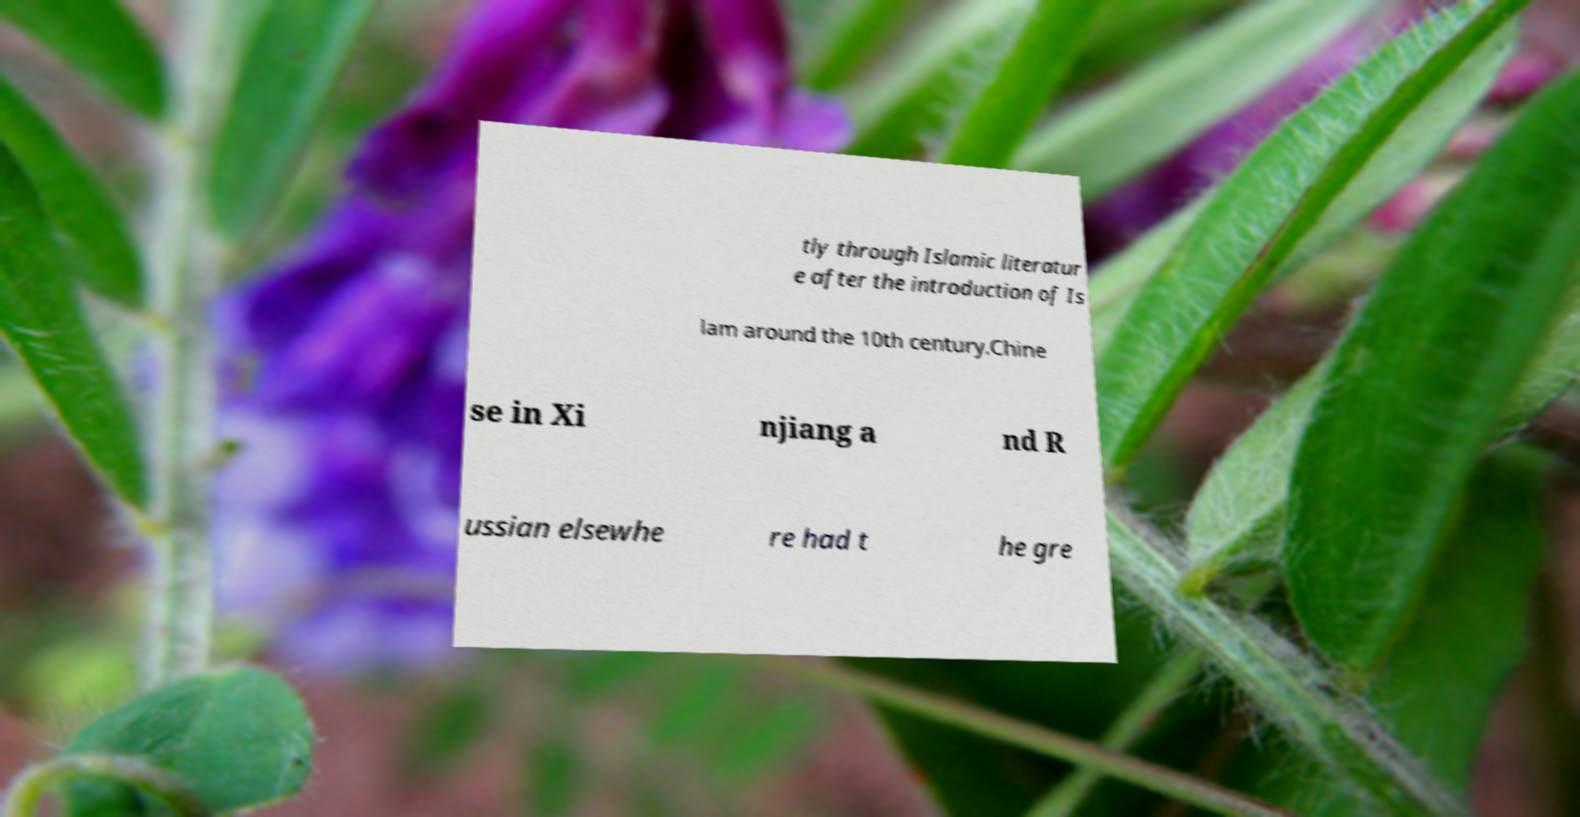Could you extract and type out the text from this image? tly through Islamic literatur e after the introduction of Is lam around the 10th century.Chine se in Xi njiang a nd R ussian elsewhe re had t he gre 